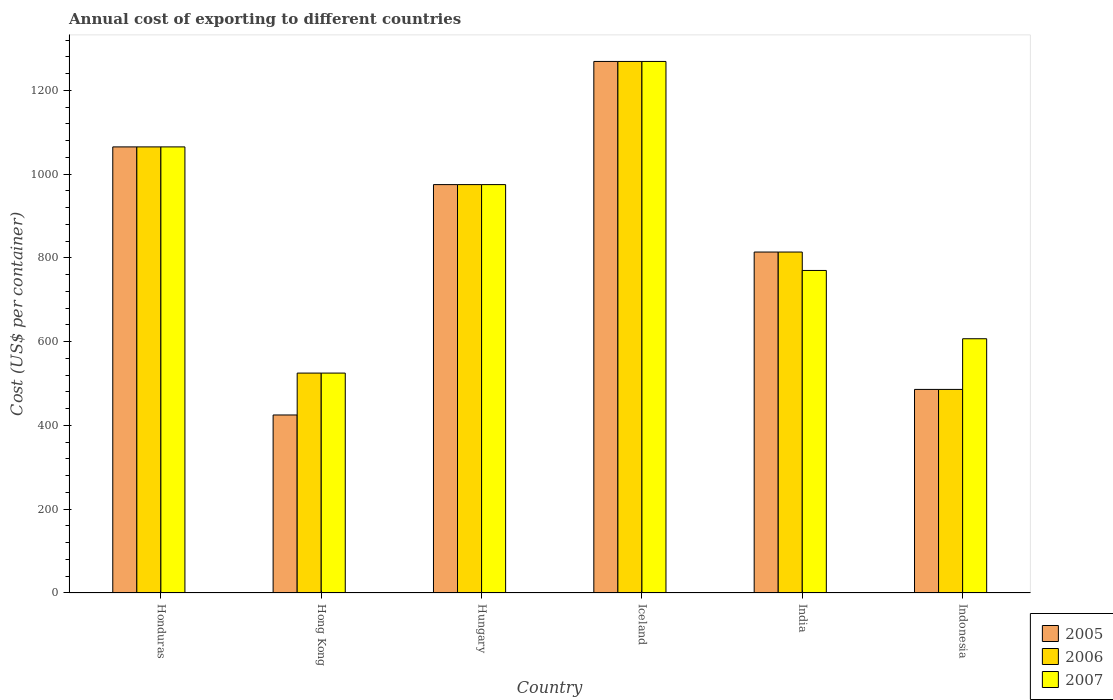How many different coloured bars are there?
Provide a short and direct response. 3. How many groups of bars are there?
Offer a very short reply. 6. Are the number of bars per tick equal to the number of legend labels?
Give a very brief answer. Yes. How many bars are there on the 6th tick from the left?
Give a very brief answer. 3. How many bars are there on the 1st tick from the right?
Your response must be concise. 3. What is the label of the 4th group of bars from the left?
Offer a very short reply. Iceland. What is the total annual cost of exporting in 2006 in Honduras?
Provide a short and direct response. 1065. Across all countries, what is the maximum total annual cost of exporting in 2007?
Your response must be concise. 1269. Across all countries, what is the minimum total annual cost of exporting in 2006?
Provide a short and direct response. 486. In which country was the total annual cost of exporting in 2005 maximum?
Provide a short and direct response. Iceland. In which country was the total annual cost of exporting in 2007 minimum?
Give a very brief answer. Hong Kong. What is the total total annual cost of exporting in 2006 in the graph?
Your response must be concise. 5134. What is the difference between the total annual cost of exporting in 2006 in Hong Kong and that in Iceland?
Your response must be concise. -744. What is the difference between the total annual cost of exporting in 2006 in India and the total annual cost of exporting in 2007 in Hong Kong?
Offer a very short reply. 289. What is the average total annual cost of exporting in 2007 per country?
Keep it short and to the point. 868.5. What is the difference between the total annual cost of exporting of/in 2005 and total annual cost of exporting of/in 2007 in Hong Kong?
Keep it short and to the point. -100. What is the ratio of the total annual cost of exporting in 2005 in Iceland to that in Indonesia?
Your answer should be compact. 2.61. Is the difference between the total annual cost of exporting in 2005 in Hungary and Indonesia greater than the difference between the total annual cost of exporting in 2007 in Hungary and Indonesia?
Provide a succinct answer. Yes. What is the difference between the highest and the second highest total annual cost of exporting in 2006?
Your answer should be very brief. -204. What is the difference between the highest and the lowest total annual cost of exporting in 2005?
Offer a terse response. 844. In how many countries, is the total annual cost of exporting in 2006 greater than the average total annual cost of exporting in 2006 taken over all countries?
Give a very brief answer. 3. Is the sum of the total annual cost of exporting in 2006 in India and Indonesia greater than the maximum total annual cost of exporting in 2007 across all countries?
Ensure brevity in your answer.  Yes. How many bars are there?
Make the answer very short. 18. Are all the bars in the graph horizontal?
Your answer should be very brief. No. Are the values on the major ticks of Y-axis written in scientific E-notation?
Make the answer very short. No. Does the graph contain grids?
Your answer should be compact. No. Where does the legend appear in the graph?
Provide a short and direct response. Bottom right. How many legend labels are there?
Your response must be concise. 3. What is the title of the graph?
Ensure brevity in your answer.  Annual cost of exporting to different countries. What is the label or title of the X-axis?
Provide a short and direct response. Country. What is the label or title of the Y-axis?
Provide a short and direct response. Cost (US$ per container). What is the Cost (US$ per container) in 2005 in Honduras?
Make the answer very short. 1065. What is the Cost (US$ per container) in 2006 in Honduras?
Give a very brief answer. 1065. What is the Cost (US$ per container) in 2007 in Honduras?
Offer a very short reply. 1065. What is the Cost (US$ per container) in 2005 in Hong Kong?
Your response must be concise. 425. What is the Cost (US$ per container) of 2006 in Hong Kong?
Offer a very short reply. 525. What is the Cost (US$ per container) in 2007 in Hong Kong?
Your answer should be compact. 525. What is the Cost (US$ per container) in 2005 in Hungary?
Make the answer very short. 975. What is the Cost (US$ per container) in 2006 in Hungary?
Offer a very short reply. 975. What is the Cost (US$ per container) in 2007 in Hungary?
Offer a very short reply. 975. What is the Cost (US$ per container) in 2005 in Iceland?
Your answer should be very brief. 1269. What is the Cost (US$ per container) in 2006 in Iceland?
Your answer should be compact. 1269. What is the Cost (US$ per container) of 2007 in Iceland?
Make the answer very short. 1269. What is the Cost (US$ per container) in 2005 in India?
Your answer should be compact. 814. What is the Cost (US$ per container) of 2006 in India?
Offer a very short reply. 814. What is the Cost (US$ per container) of 2007 in India?
Give a very brief answer. 770. What is the Cost (US$ per container) in 2005 in Indonesia?
Keep it short and to the point. 486. What is the Cost (US$ per container) in 2006 in Indonesia?
Provide a succinct answer. 486. What is the Cost (US$ per container) in 2007 in Indonesia?
Ensure brevity in your answer.  607. Across all countries, what is the maximum Cost (US$ per container) in 2005?
Make the answer very short. 1269. Across all countries, what is the maximum Cost (US$ per container) in 2006?
Give a very brief answer. 1269. Across all countries, what is the maximum Cost (US$ per container) in 2007?
Your response must be concise. 1269. Across all countries, what is the minimum Cost (US$ per container) of 2005?
Provide a succinct answer. 425. Across all countries, what is the minimum Cost (US$ per container) in 2006?
Keep it short and to the point. 486. Across all countries, what is the minimum Cost (US$ per container) in 2007?
Your answer should be very brief. 525. What is the total Cost (US$ per container) of 2005 in the graph?
Your response must be concise. 5034. What is the total Cost (US$ per container) in 2006 in the graph?
Offer a terse response. 5134. What is the total Cost (US$ per container) of 2007 in the graph?
Provide a succinct answer. 5211. What is the difference between the Cost (US$ per container) of 2005 in Honduras and that in Hong Kong?
Ensure brevity in your answer.  640. What is the difference between the Cost (US$ per container) of 2006 in Honduras and that in Hong Kong?
Ensure brevity in your answer.  540. What is the difference between the Cost (US$ per container) of 2007 in Honduras and that in Hong Kong?
Keep it short and to the point. 540. What is the difference between the Cost (US$ per container) of 2006 in Honduras and that in Hungary?
Make the answer very short. 90. What is the difference between the Cost (US$ per container) of 2005 in Honduras and that in Iceland?
Keep it short and to the point. -204. What is the difference between the Cost (US$ per container) of 2006 in Honduras and that in Iceland?
Give a very brief answer. -204. What is the difference between the Cost (US$ per container) of 2007 in Honduras and that in Iceland?
Your answer should be very brief. -204. What is the difference between the Cost (US$ per container) of 2005 in Honduras and that in India?
Your answer should be very brief. 251. What is the difference between the Cost (US$ per container) in 2006 in Honduras and that in India?
Keep it short and to the point. 251. What is the difference between the Cost (US$ per container) of 2007 in Honduras and that in India?
Give a very brief answer. 295. What is the difference between the Cost (US$ per container) of 2005 in Honduras and that in Indonesia?
Give a very brief answer. 579. What is the difference between the Cost (US$ per container) in 2006 in Honduras and that in Indonesia?
Your answer should be compact. 579. What is the difference between the Cost (US$ per container) in 2007 in Honduras and that in Indonesia?
Your answer should be very brief. 458. What is the difference between the Cost (US$ per container) in 2005 in Hong Kong and that in Hungary?
Your answer should be compact. -550. What is the difference between the Cost (US$ per container) of 2006 in Hong Kong and that in Hungary?
Your response must be concise. -450. What is the difference between the Cost (US$ per container) in 2007 in Hong Kong and that in Hungary?
Your answer should be very brief. -450. What is the difference between the Cost (US$ per container) in 2005 in Hong Kong and that in Iceland?
Your answer should be very brief. -844. What is the difference between the Cost (US$ per container) in 2006 in Hong Kong and that in Iceland?
Your answer should be very brief. -744. What is the difference between the Cost (US$ per container) of 2007 in Hong Kong and that in Iceland?
Your answer should be very brief. -744. What is the difference between the Cost (US$ per container) in 2005 in Hong Kong and that in India?
Provide a succinct answer. -389. What is the difference between the Cost (US$ per container) in 2006 in Hong Kong and that in India?
Provide a short and direct response. -289. What is the difference between the Cost (US$ per container) of 2007 in Hong Kong and that in India?
Your answer should be very brief. -245. What is the difference between the Cost (US$ per container) in 2005 in Hong Kong and that in Indonesia?
Ensure brevity in your answer.  -61. What is the difference between the Cost (US$ per container) of 2006 in Hong Kong and that in Indonesia?
Offer a terse response. 39. What is the difference between the Cost (US$ per container) in 2007 in Hong Kong and that in Indonesia?
Keep it short and to the point. -82. What is the difference between the Cost (US$ per container) in 2005 in Hungary and that in Iceland?
Ensure brevity in your answer.  -294. What is the difference between the Cost (US$ per container) of 2006 in Hungary and that in Iceland?
Provide a succinct answer. -294. What is the difference between the Cost (US$ per container) of 2007 in Hungary and that in Iceland?
Provide a succinct answer. -294. What is the difference between the Cost (US$ per container) of 2005 in Hungary and that in India?
Give a very brief answer. 161. What is the difference between the Cost (US$ per container) of 2006 in Hungary and that in India?
Give a very brief answer. 161. What is the difference between the Cost (US$ per container) in 2007 in Hungary and that in India?
Give a very brief answer. 205. What is the difference between the Cost (US$ per container) of 2005 in Hungary and that in Indonesia?
Your answer should be compact. 489. What is the difference between the Cost (US$ per container) of 2006 in Hungary and that in Indonesia?
Ensure brevity in your answer.  489. What is the difference between the Cost (US$ per container) in 2007 in Hungary and that in Indonesia?
Provide a short and direct response. 368. What is the difference between the Cost (US$ per container) in 2005 in Iceland and that in India?
Provide a short and direct response. 455. What is the difference between the Cost (US$ per container) of 2006 in Iceland and that in India?
Make the answer very short. 455. What is the difference between the Cost (US$ per container) in 2007 in Iceland and that in India?
Keep it short and to the point. 499. What is the difference between the Cost (US$ per container) in 2005 in Iceland and that in Indonesia?
Keep it short and to the point. 783. What is the difference between the Cost (US$ per container) in 2006 in Iceland and that in Indonesia?
Provide a succinct answer. 783. What is the difference between the Cost (US$ per container) of 2007 in Iceland and that in Indonesia?
Your response must be concise. 662. What is the difference between the Cost (US$ per container) in 2005 in India and that in Indonesia?
Offer a very short reply. 328. What is the difference between the Cost (US$ per container) of 2006 in India and that in Indonesia?
Offer a terse response. 328. What is the difference between the Cost (US$ per container) of 2007 in India and that in Indonesia?
Your response must be concise. 163. What is the difference between the Cost (US$ per container) in 2005 in Honduras and the Cost (US$ per container) in 2006 in Hong Kong?
Offer a very short reply. 540. What is the difference between the Cost (US$ per container) of 2005 in Honduras and the Cost (US$ per container) of 2007 in Hong Kong?
Offer a very short reply. 540. What is the difference between the Cost (US$ per container) in 2006 in Honduras and the Cost (US$ per container) in 2007 in Hong Kong?
Keep it short and to the point. 540. What is the difference between the Cost (US$ per container) in 2005 in Honduras and the Cost (US$ per container) in 2007 in Hungary?
Ensure brevity in your answer.  90. What is the difference between the Cost (US$ per container) in 2005 in Honduras and the Cost (US$ per container) in 2006 in Iceland?
Give a very brief answer. -204. What is the difference between the Cost (US$ per container) of 2005 in Honduras and the Cost (US$ per container) of 2007 in Iceland?
Your answer should be very brief. -204. What is the difference between the Cost (US$ per container) in 2006 in Honduras and the Cost (US$ per container) in 2007 in Iceland?
Your answer should be very brief. -204. What is the difference between the Cost (US$ per container) in 2005 in Honduras and the Cost (US$ per container) in 2006 in India?
Your answer should be compact. 251. What is the difference between the Cost (US$ per container) of 2005 in Honduras and the Cost (US$ per container) of 2007 in India?
Provide a succinct answer. 295. What is the difference between the Cost (US$ per container) in 2006 in Honduras and the Cost (US$ per container) in 2007 in India?
Ensure brevity in your answer.  295. What is the difference between the Cost (US$ per container) of 2005 in Honduras and the Cost (US$ per container) of 2006 in Indonesia?
Your answer should be compact. 579. What is the difference between the Cost (US$ per container) in 2005 in Honduras and the Cost (US$ per container) in 2007 in Indonesia?
Keep it short and to the point. 458. What is the difference between the Cost (US$ per container) in 2006 in Honduras and the Cost (US$ per container) in 2007 in Indonesia?
Provide a short and direct response. 458. What is the difference between the Cost (US$ per container) in 2005 in Hong Kong and the Cost (US$ per container) in 2006 in Hungary?
Ensure brevity in your answer.  -550. What is the difference between the Cost (US$ per container) in 2005 in Hong Kong and the Cost (US$ per container) in 2007 in Hungary?
Provide a short and direct response. -550. What is the difference between the Cost (US$ per container) in 2006 in Hong Kong and the Cost (US$ per container) in 2007 in Hungary?
Provide a succinct answer. -450. What is the difference between the Cost (US$ per container) of 2005 in Hong Kong and the Cost (US$ per container) of 2006 in Iceland?
Give a very brief answer. -844. What is the difference between the Cost (US$ per container) in 2005 in Hong Kong and the Cost (US$ per container) in 2007 in Iceland?
Make the answer very short. -844. What is the difference between the Cost (US$ per container) of 2006 in Hong Kong and the Cost (US$ per container) of 2007 in Iceland?
Provide a short and direct response. -744. What is the difference between the Cost (US$ per container) of 2005 in Hong Kong and the Cost (US$ per container) of 2006 in India?
Give a very brief answer. -389. What is the difference between the Cost (US$ per container) of 2005 in Hong Kong and the Cost (US$ per container) of 2007 in India?
Give a very brief answer. -345. What is the difference between the Cost (US$ per container) of 2006 in Hong Kong and the Cost (US$ per container) of 2007 in India?
Give a very brief answer. -245. What is the difference between the Cost (US$ per container) in 2005 in Hong Kong and the Cost (US$ per container) in 2006 in Indonesia?
Your answer should be compact. -61. What is the difference between the Cost (US$ per container) in 2005 in Hong Kong and the Cost (US$ per container) in 2007 in Indonesia?
Offer a terse response. -182. What is the difference between the Cost (US$ per container) of 2006 in Hong Kong and the Cost (US$ per container) of 2007 in Indonesia?
Your answer should be compact. -82. What is the difference between the Cost (US$ per container) of 2005 in Hungary and the Cost (US$ per container) of 2006 in Iceland?
Provide a succinct answer. -294. What is the difference between the Cost (US$ per container) of 2005 in Hungary and the Cost (US$ per container) of 2007 in Iceland?
Offer a very short reply. -294. What is the difference between the Cost (US$ per container) in 2006 in Hungary and the Cost (US$ per container) in 2007 in Iceland?
Ensure brevity in your answer.  -294. What is the difference between the Cost (US$ per container) in 2005 in Hungary and the Cost (US$ per container) in 2006 in India?
Offer a terse response. 161. What is the difference between the Cost (US$ per container) of 2005 in Hungary and the Cost (US$ per container) of 2007 in India?
Ensure brevity in your answer.  205. What is the difference between the Cost (US$ per container) in 2006 in Hungary and the Cost (US$ per container) in 2007 in India?
Your answer should be compact. 205. What is the difference between the Cost (US$ per container) in 2005 in Hungary and the Cost (US$ per container) in 2006 in Indonesia?
Your response must be concise. 489. What is the difference between the Cost (US$ per container) of 2005 in Hungary and the Cost (US$ per container) of 2007 in Indonesia?
Offer a very short reply. 368. What is the difference between the Cost (US$ per container) in 2006 in Hungary and the Cost (US$ per container) in 2007 in Indonesia?
Give a very brief answer. 368. What is the difference between the Cost (US$ per container) of 2005 in Iceland and the Cost (US$ per container) of 2006 in India?
Offer a very short reply. 455. What is the difference between the Cost (US$ per container) in 2005 in Iceland and the Cost (US$ per container) in 2007 in India?
Provide a short and direct response. 499. What is the difference between the Cost (US$ per container) of 2006 in Iceland and the Cost (US$ per container) of 2007 in India?
Give a very brief answer. 499. What is the difference between the Cost (US$ per container) of 2005 in Iceland and the Cost (US$ per container) of 2006 in Indonesia?
Your answer should be compact. 783. What is the difference between the Cost (US$ per container) in 2005 in Iceland and the Cost (US$ per container) in 2007 in Indonesia?
Ensure brevity in your answer.  662. What is the difference between the Cost (US$ per container) in 2006 in Iceland and the Cost (US$ per container) in 2007 in Indonesia?
Ensure brevity in your answer.  662. What is the difference between the Cost (US$ per container) of 2005 in India and the Cost (US$ per container) of 2006 in Indonesia?
Give a very brief answer. 328. What is the difference between the Cost (US$ per container) in 2005 in India and the Cost (US$ per container) in 2007 in Indonesia?
Give a very brief answer. 207. What is the difference between the Cost (US$ per container) in 2006 in India and the Cost (US$ per container) in 2007 in Indonesia?
Provide a succinct answer. 207. What is the average Cost (US$ per container) in 2005 per country?
Keep it short and to the point. 839. What is the average Cost (US$ per container) of 2006 per country?
Make the answer very short. 855.67. What is the average Cost (US$ per container) of 2007 per country?
Your answer should be very brief. 868.5. What is the difference between the Cost (US$ per container) in 2005 and Cost (US$ per container) in 2007 in Honduras?
Your answer should be very brief. 0. What is the difference between the Cost (US$ per container) of 2005 and Cost (US$ per container) of 2006 in Hong Kong?
Keep it short and to the point. -100. What is the difference between the Cost (US$ per container) in 2005 and Cost (US$ per container) in 2007 in Hong Kong?
Give a very brief answer. -100. What is the difference between the Cost (US$ per container) in 2005 and Cost (US$ per container) in 2007 in Iceland?
Your answer should be compact. 0. What is the difference between the Cost (US$ per container) of 2005 and Cost (US$ per container) of 2006 in India?
Give a very brief answer. 0. What is the difference between the Cost (US$ per container) in 2005 and Cost (US$ per container) in 2007 in India?
Provide a short and direct response. 44. What is the difference between the Cost (US$ per container) of 2005 and Cost (US$ per container) of 2006 in Indonesia?
Offer a terse response. 0. What is the difference between the Cost (US$ per container) in 2005 and Cost (US$ per container) in 2007 in Indonesia?
Keep it short and to the point. -121. What is the difference between the Cost (US$ per container) in 2006 and Cost (US$ per container) in 2007 in Indonesia?
Make the answer very short. -121. What is the ratio of the Cost (US$ per container) in 2005 in Honduras to that in Hong Kong?
Provide a short and direct response. 2.51. What is the ratio of the Cost (US$ per container) of 2006 in Honduras to that in Hong Kong?
Offer a very short reply. 2.03. What is the ratio of the Cost (US$ per container) of 2007 in Honduras to that in Hong Kong?
Keep it short and to the point. 2.03. What is the ratio of the Cost (US$ per container) of 2005 in Honduras to that in Hungary?
Your answer should be compact. 1.09. What is the ratio of the Cost (US$ per container) of 2006 in Honduras to that in Hungary?
Keep it short and to the point. 1.09. What is the ratio of the Cost (US$ per container) of 2007 in Honduras to that in Hungary?
Your answer should be very brief. 1.09. What is the ratio of the Cost (US$ per container) in 2005 in Honduras to that in Iceland?
Provide a short and direct response. 0.84. What is the ratio of the Cost (US$ per container) of 2006 in Honduras to that in Iceland?
Make the answer very short. 0.84. What is the ratio of the Cost (US$ per container) of 2007 in Honduras to that in Iceland?
Keep it short and to the point. 0.84. What is the ratio of the Cost (US$ per container) of 2005 in Honduras to that in India?
Make the answer very short. 1.31. What is the ratio of the Cost (US$ per container) of 2006 in Honduras to that in India?
Ensure brevity in your answer.  1.31. What is the ratio of the Cost (US$ per container) of 2007 in Honduras to that in India?
Your response must be concise. 1.38. What is the ratio of the Cost (US$ per container) of 2005 in Honduras to that in Indonesia?
Ensure brevity in your answer.  2.19. What is the ratio of the Cost (US$ per container) of 2006 in Honduras to that in Indonesia?
Ensure brevity in your answer.  2.19. What is the ratio of the Cost (US$ per container) of 2007 in Honduras to that in Indonesia?
Give a very brief answer. 1.75. What is the ratio of the Cost (US$ per container) in 2005 in Hong Kong to that in Hungary?
Keep it short and to the point. 0.44. What is the ratio of the Cost (US$ per container) in 2006 in Hong Kong to that in Hungary?
Provide a short and direct response. 0.54. What is the ratio of the Cost (US$ per container) in 2007 in Hong Kong to that in Hungary?
Offer a very short reply. 0.54. What is the ratio of the Cost (US$ per container) of 2005 in Hong Kong to that in Iceland?
Your response must be concise. 0.33. What is the ratio of the Cost (US$ per container) in 2006 in Hong Kong to that in Iceland?
Offer a terse response. 0.41. What is the ratio of the Cost (US$ per container) in 2007 in Hong Kong to that in Iceland?
Provide a succinct answer. 0.41. What is the ratio of the Cost (US$ per container) in 2005 in Hong Kong to that in India?
Make the answer very short. 0.52. What is the ratio of the Cost (US$ per container) in 2006 in Hong Kong to that in India?
Keep it short and to the point. 0.65. What is the ratio of the Cost (US$ per container) in 2007 in Hong Kong to that in India?
Offer a terse response. 0.68. What is the ratio of the Cost (US$ per container) of 2005 in Hong Kong to that in Indonesia?
Make the answer very short. 0.87. What is the ratio of the Cost (US$ per container) in 2006 in Hong Kong to that in Indonesia?
Make the answer very short. 1.08. What is the ratio of the Cost (US$ per container) of 2007 in Hong Kong to that in Indonesia?
Provide a short and direct response. 0.86. What is the ratio of the Cost (US$ per container) of 2005 in Hungary to that in Iceland?
Provide a succinct answer. 0.77. What is the ratio of the Cost (US$ per container) of 2006 in Hungary to that in Iceland?
Keep it short and to the point. 0.77. What is the ratio of the Cost (US$ per container) of 2007 in Hungary to that in Iceland?
Keep it short and to the point. 0.77. What is the ratio of the Cost (US$ per container) of 2005 in Hungary to that in India?
Keep it short and to the point. 1.2. What is the ratio of the Cost (US$ per container) in 2006 in Hungary to that in India?
Offer a very short reply. 1.2. What is the ratio of the Cost (US$ per container) of 2007 in Hungary to that in India?
Your answer should be compact. 1.27. What is the ratio of the Cost (US$ per container) of 2005 in Hungary to that in Indonesia?
Your response must be concise. 2.01. What is the ratio of the Cost (US$ per container) in 2006 in Hungary to that in Indonesia?
Ensure brevity in your answer.  2.01. What is the ratio of the Cost (US$ per container) of 2007 in Hungary to that in Indonesia?
Ensure brevity in your answer.  1.61. What is the ratio of the Cost (US$ per container) in 2005 in Iceland to that in India?
Your answer should be very brief. 1.56. What is the ratio of the Cost (US$ per container) of 2006 in Iceland to that in India?
Provide a short and direct response. 1.56. What is the ratio of the Cost (US$ per container) in 2007 in Iceland to that in India?
Keep it short and to the point. 1.65. What is the ratio of the Cost (US$ per container) of 2005 in Iceland to that in Indonesia?
Give a very brief answer. 2.61. What is the ratio of the Cost (US$ per container) in 2006 in Iceland to that in Indonesia?
Keep it short and to the point. 2.61. What is the ratio of the Cost (US$ per container) in 2007 in Iceland to that in Indonesia?
Provide a short and direct response. 2.09. What is the ratio of the Cost (US$ per container) in 2005 in India to that in Indonesia?
Make the answer very short. 1.67. What is the ratio of the Cost (US$ per container) of 2006 in India to that in Indonesia?
Keep it short and to the point. 1.67. What is the ratio of the Cost (US$ per container) of 2007 in India to that in Indonesia?
Offer a terse response. 1.27. What is the difference between the highest and the second highest Cost (US$ per container) of 2005?
Your answer should be compact. 204. What is the difference between the highest and the second highest Cost (US$ per container) of 2006?
Your answer should be compact. 204. What is the difference between the highest and the second highest Cost (US$ per container) in 2007?
Provide a short and direct response. 204. What is the difference between the highest and the lowest Cost (US$ per container) of 2005?
Your answer should be compact. 844. What is the difference between the highest and the lowest Cost (US$ per container) in 2006?
Offer a terse response. 783. What is the difference between the highest and the lowest Cost (US$ per container) of 2007?
Offer a very short reply. 744. 